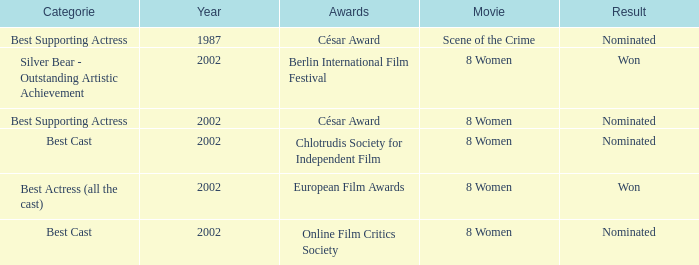In what year was the movie 8 women up for a César Award? 2002.0. 